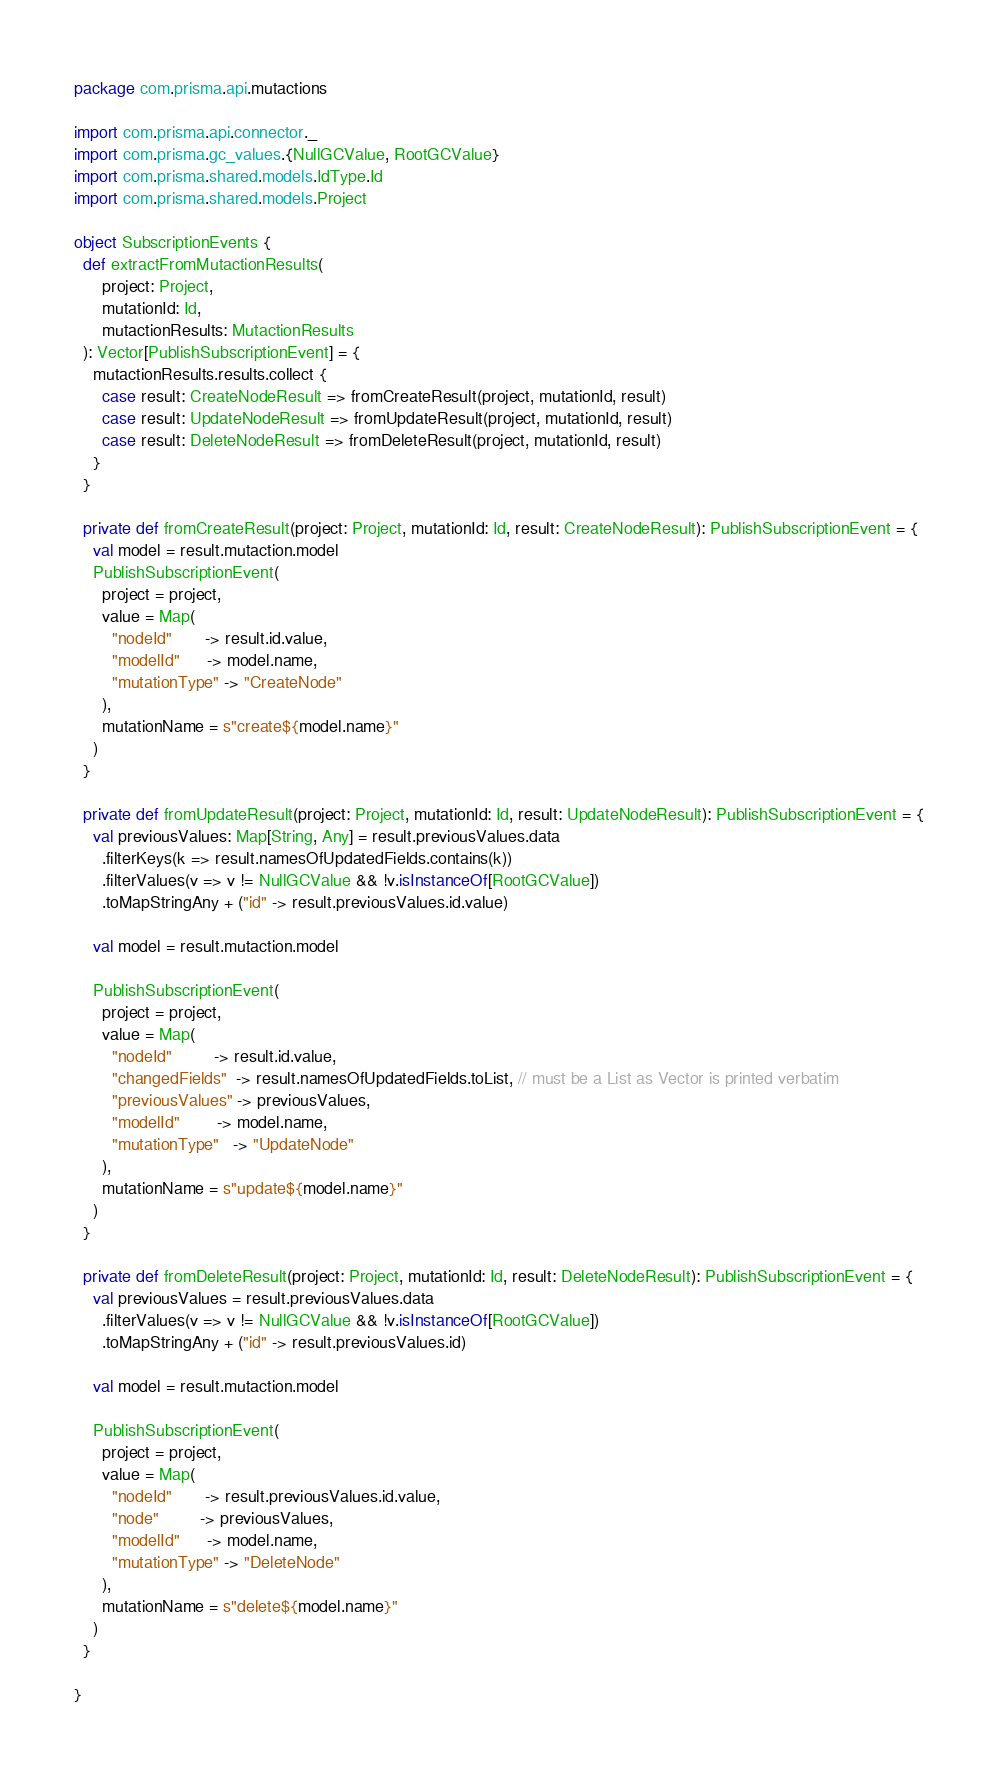Convert code to text. <code><loc_0><loc_0><loc_500><loc_500><_Scala_>package com.prisma.api.mutactions

import com.prisma.api.connector._
import com.prisma.gc_values.{NullGCValue, RootGCValue}
import com.prisma.shared.models.IdType.Id
import com.prisma.shared.models.Project

object SubscriptionEvents {
  def extractFromMutactionResults(
      project: Project,
      mutationId: Id,
      mutactionResults: MutactionResults
  ): Vector[PublishSubscriptionEvent] = {
    mutactionResults.results.collect {
      case result: CreateNodeResult => fromCreateResult(project, mutationId, result)
      case result: UpdateNodeResult => fromUpdateResult(project, mutationId, result)
      case result: DeleteNodeResult => fromDeleteResult(project, mutationId, result)
    }
  }

  private def fromCreateResult(project: Project, mutationId: Id, result: CreateNodeResult): PublishSubscriptionEvent = {
    val model = result.mutaction.model
    PublishSubscriptionEvent(
      project = project,
      value = Map(
        "nodeId"       -> result.id.value,
        "modelId"      -> model.name,
        "mutationType" -> "CreateNode"
      ),
      mutationName = s"create${model.name}"
    )
  }

  private def fromUpdateResult(project: Project, mutationId: Id, result: UpdateNodeResult): PublishSubscriptionEvent = {
    val previousValues: Map[String, Any] = result.previousValues.data
      .filterKeys(k => result.namesOfUpdatedFields.contains(k))
      .filterValues(v => v != NullGCValue && !v.isInstanceOf[RootGCValue])
      .toMapStringAny + ("id" -> result.previousValues.id.value)

    val model = result.mutaction.model

    PublishSubscriptionEvent(
      project = project,
      value = Map(
        "nodeId"         -> result.id.value,
        "changedFields"  -> result.namesOfUpdatedFields.toList, // must be a List as Vector is printed verbatim
        "previousValues" -> previousValues,
        "modelId"        -> model.name,
        "mutationType"   -> "UpdateNode"
      ),
      mutationName = s"update${model.name}"
    )
  }

  private def fromDeleteResult(project: Project, mutationId: Id, result: DeleteNodeResult): PublishSubscriptionEvent = {
    val previousValues = result.previousValues.data
      .filterValues(v => v != NullGCValue && !v.isInstanceOf[RootGCValue])
      .toMapStringAny + ("id" -> result.previousValues.id)

    val model = result.mutaction.model

    PublishSubscriptionEvent(
      project = project,
      value = Map(
        "nodeId"       -> result.previousValues.id.value,
        "node"         -> previousValues,
        "modelId"      -> model.name,
        "mutationType" -> "DeleteNode"
      ),
      mutationName = s"delete${model.name}"
    )
  }

}
</code> 